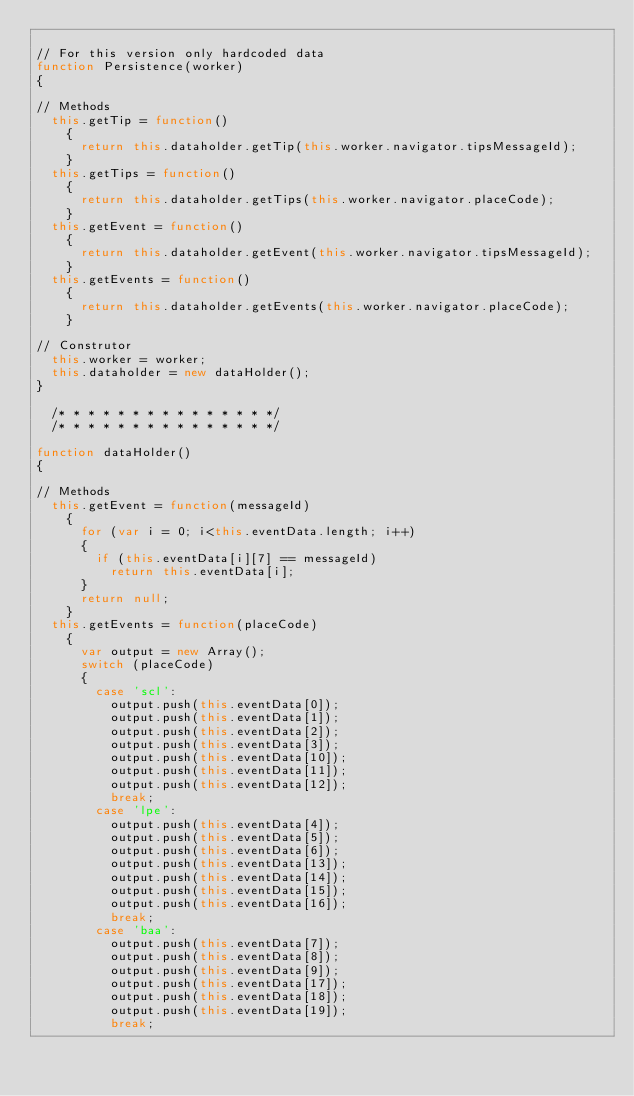Convert code to text. <code><loc_0><loc_0><loc_500><loc_500><_JavaScript_>
// For this version only hardcoded data
function Persistence(worker)
{

// Methods
	this.getTip = function()
		{
			return this.dataholder.getTip(this.worker.navigator.tipsMessageId);
		}
	this.getTips = function()
		{
			return this.dataholder.getTips(this.worker.navigator.placeCode);
		}
	this.getEvent = function()
		{
			return this.dataholder.getEvent(this.worker.navigator.tipsMessageId);
		}
	this.getEvents = function()
		{
			return this.dataholder.getEvents(this.worker.navigator.placeCode);
		}
	
// Construtor
	this.worker = worker;
	this.dataholder = new dataHolder();
}

	/* * * * * * * * * * * * * * */
	/* * * * * * * * * * * * * * */

function dataHolder()
{

// Methods
	this.getEvent = function(messageId)
		{
			for (var i = 0; i<this.eventData.length; i++)
			{
				if (this.eventData[i][7] == messageId)
					return this.eventData[i];
			}
			return null;
		}
	this.getEvents = function(placeCode)
		{
			var output = new Array();
			switch (placeCode)
			{
				case 'scl':
					output.push(this.eventData[0]);
					output.push(this.eventData[1]);
					output.push(this.eventData[2]);
					output.push(this.eventData[3]);
					output.push(this.eventData[10]);
					output.push(this.eventData[11]);
					output.push(this.eventData[12]);
					break;
				case 'lpe':
					output.push(this.eventData[4]);
					output.push(this.eventData[5]);
					output.push(this.eventData[6]);
					output.push(this.eventData[13]);
					output.push(this.eventData[14]);
					output.push(this.eventData[15]);
					output.push(this.eventData[16]);
					break;
				case 'baa':
					output.push(this.eventData[7]);
					output.push(this.eventData[8]);
					output.push(this.eventData[9]);
					output.push(this.eventData[17]);
					output.push(this.eventData[18]);
					output.push(this.eventData[19]);
					break;</code> 